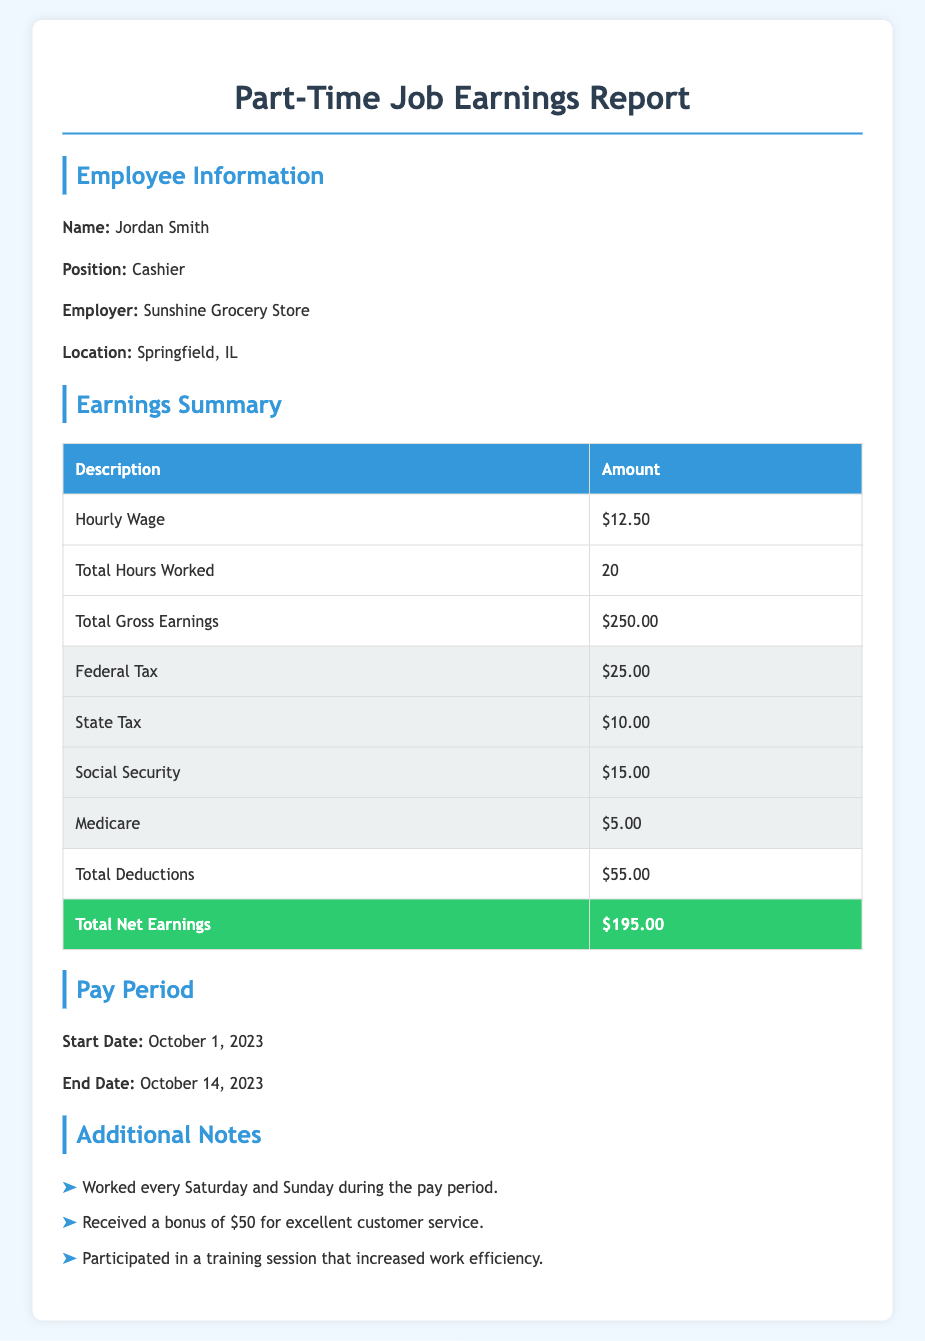What is the employee's name? The employee's name is stated in the document under Employee Information.
Answer: Jordan Smith What is the hourly wage? The hourly wage is specified in the Earnings Summary section of the document.
Answer: $12.50 What are the total hours worked? The total hours worked is provided in the Earnings Summary and indicates how many hours were recorded in the pay period.
Answer: 20 What is the total gross earnings? Total gross earnings are shown in the Earnings Summary as the total amount earned before deductions.
Answer: $250.00 What is the total deductions? Total deductions represent the sum of all deductions listed in the document, found in the Earnings Summary.
Answer: $55.00 What is the total net earnings? Total net earnings are given as the final amount earned after deductions in the document.
Answer: $195.00 What is the start date of the pay period? The start date is outlined in the Pay Period section of the report, indicating when the earnings were calculated.
Answer: October 1, 2023 What is the end date of the pay period? The end date is also found in the Pay Period section, marking the conclusion of the listed earnings.
Answer: October 14, 2023 What bonus did the employee receive? The bonus is mentioned in the Additional Notes section, which highlights any additional earnings outside of regular wages.
Answer: $50 